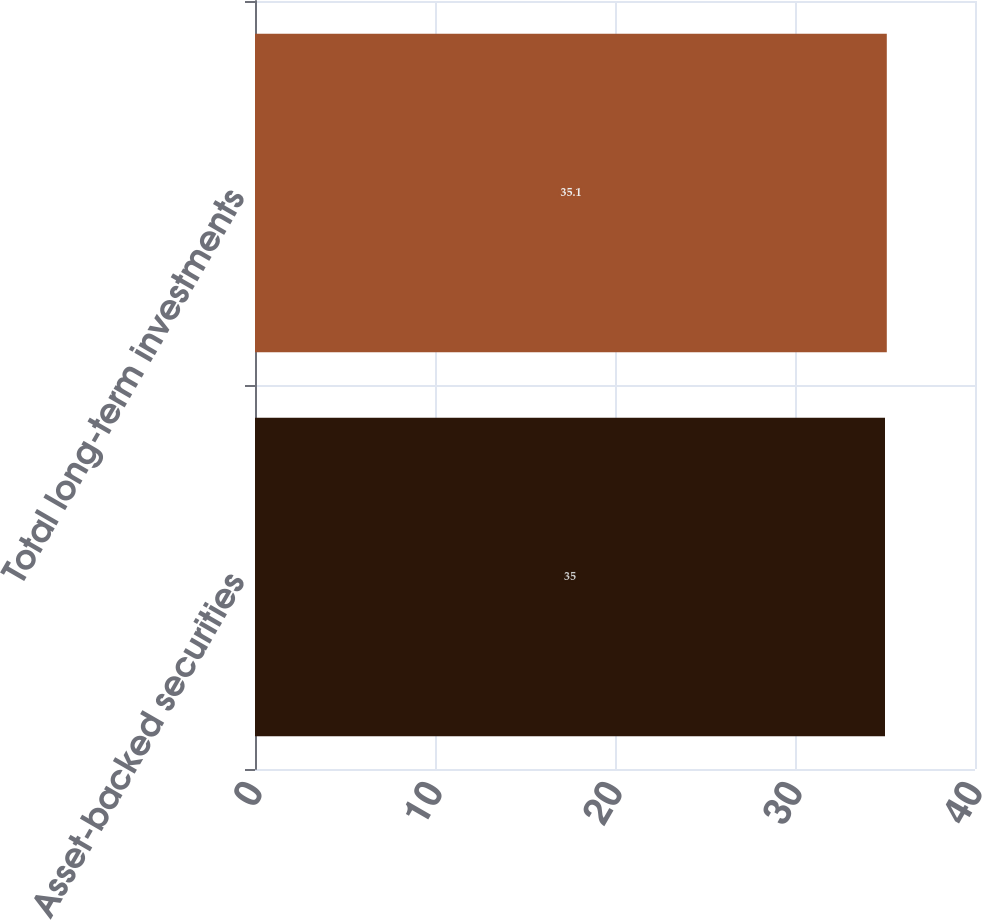<chart> <loc_0><loc_0><loc_500><loc_500><bar_chart><fcel>Asset-backed securities<fcel>Total long-term investments<nl><fcel>35<fcel>35.1<nl></chart> 